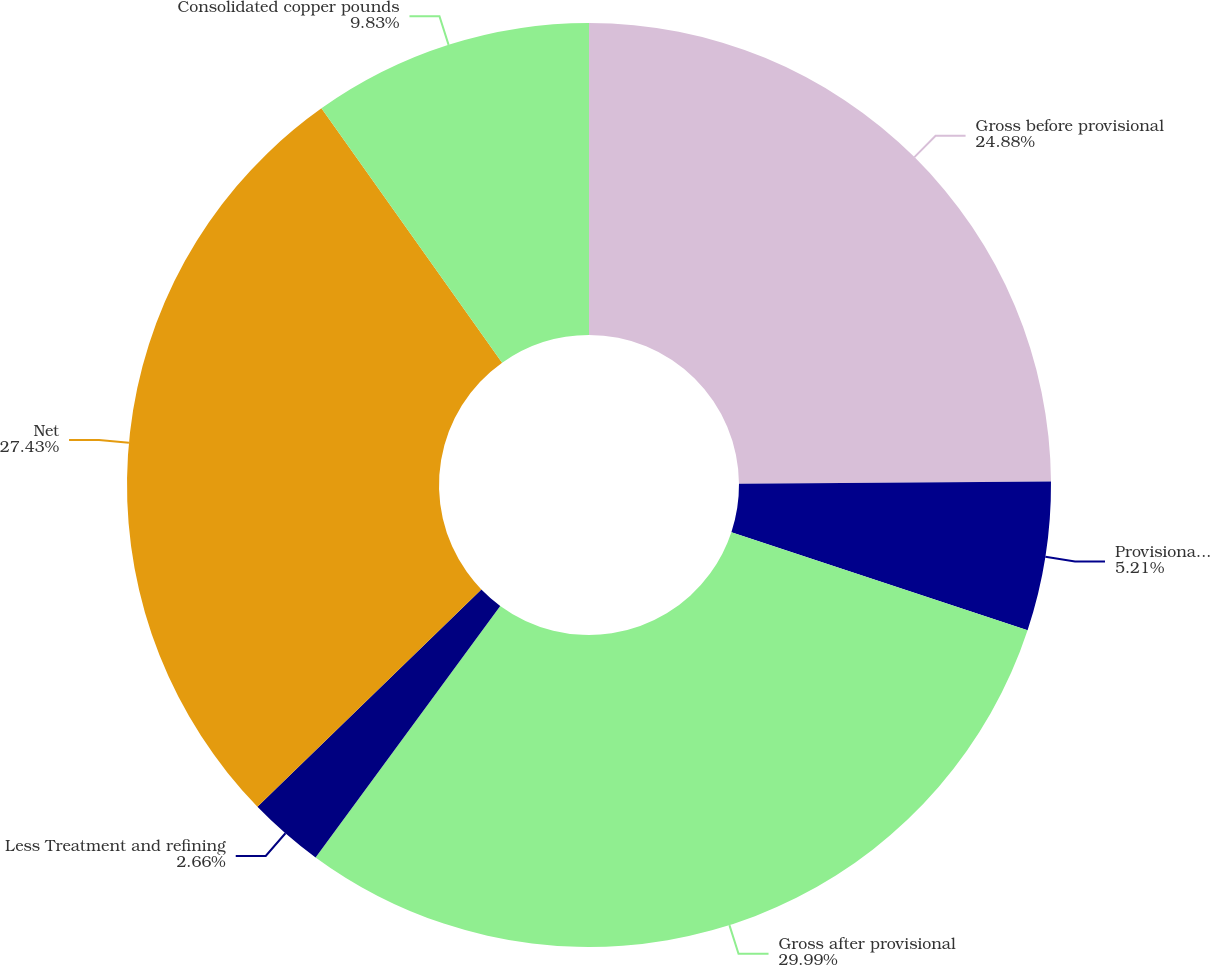<chart> <loc_0><loc_0><loc_500><loc_500><pie_chart><fcel>Gross before provisional<fcel>Provisional pricing<fcel>Gross after provisional<fcel>Less Treatment and refining<fcel>Net<fcel>Consolidated copper pounds<nl><fcel>24.88%<fcel>5.21%<fcel>29.99%<fcel>2.66%<fcel>27.43%<fcel>9.83%<nl></chart> 